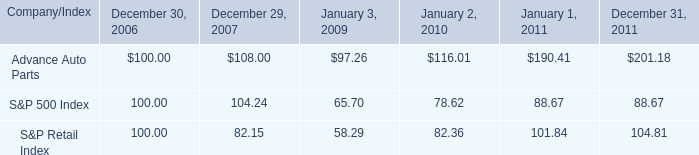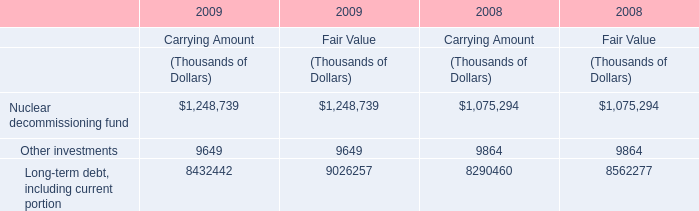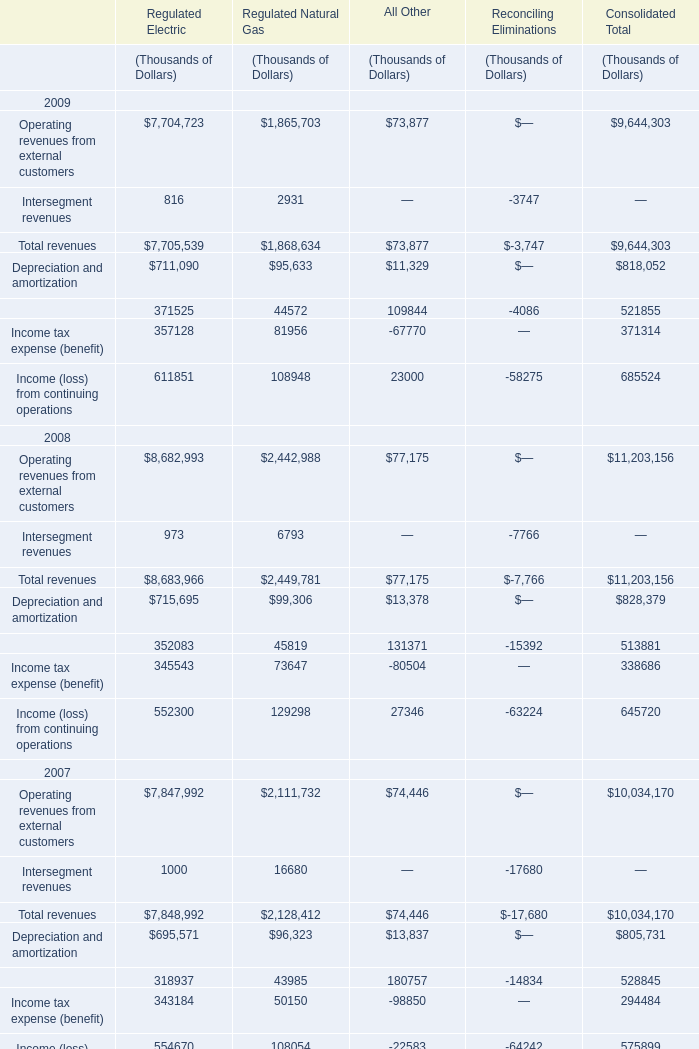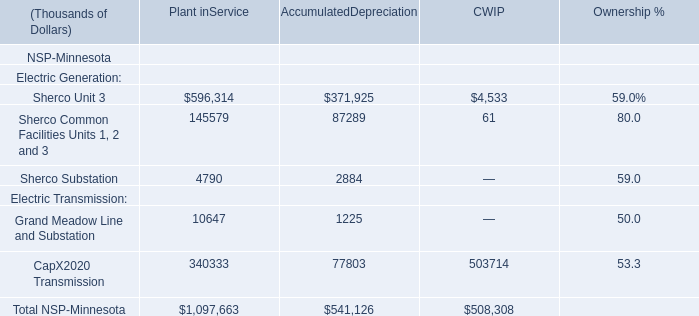what is the roi of an investment in advance auto parts from 2006 to january 3 , 2009? 
Computations: ((97.26 - 100) / 100)
Answer: -0.0274. 